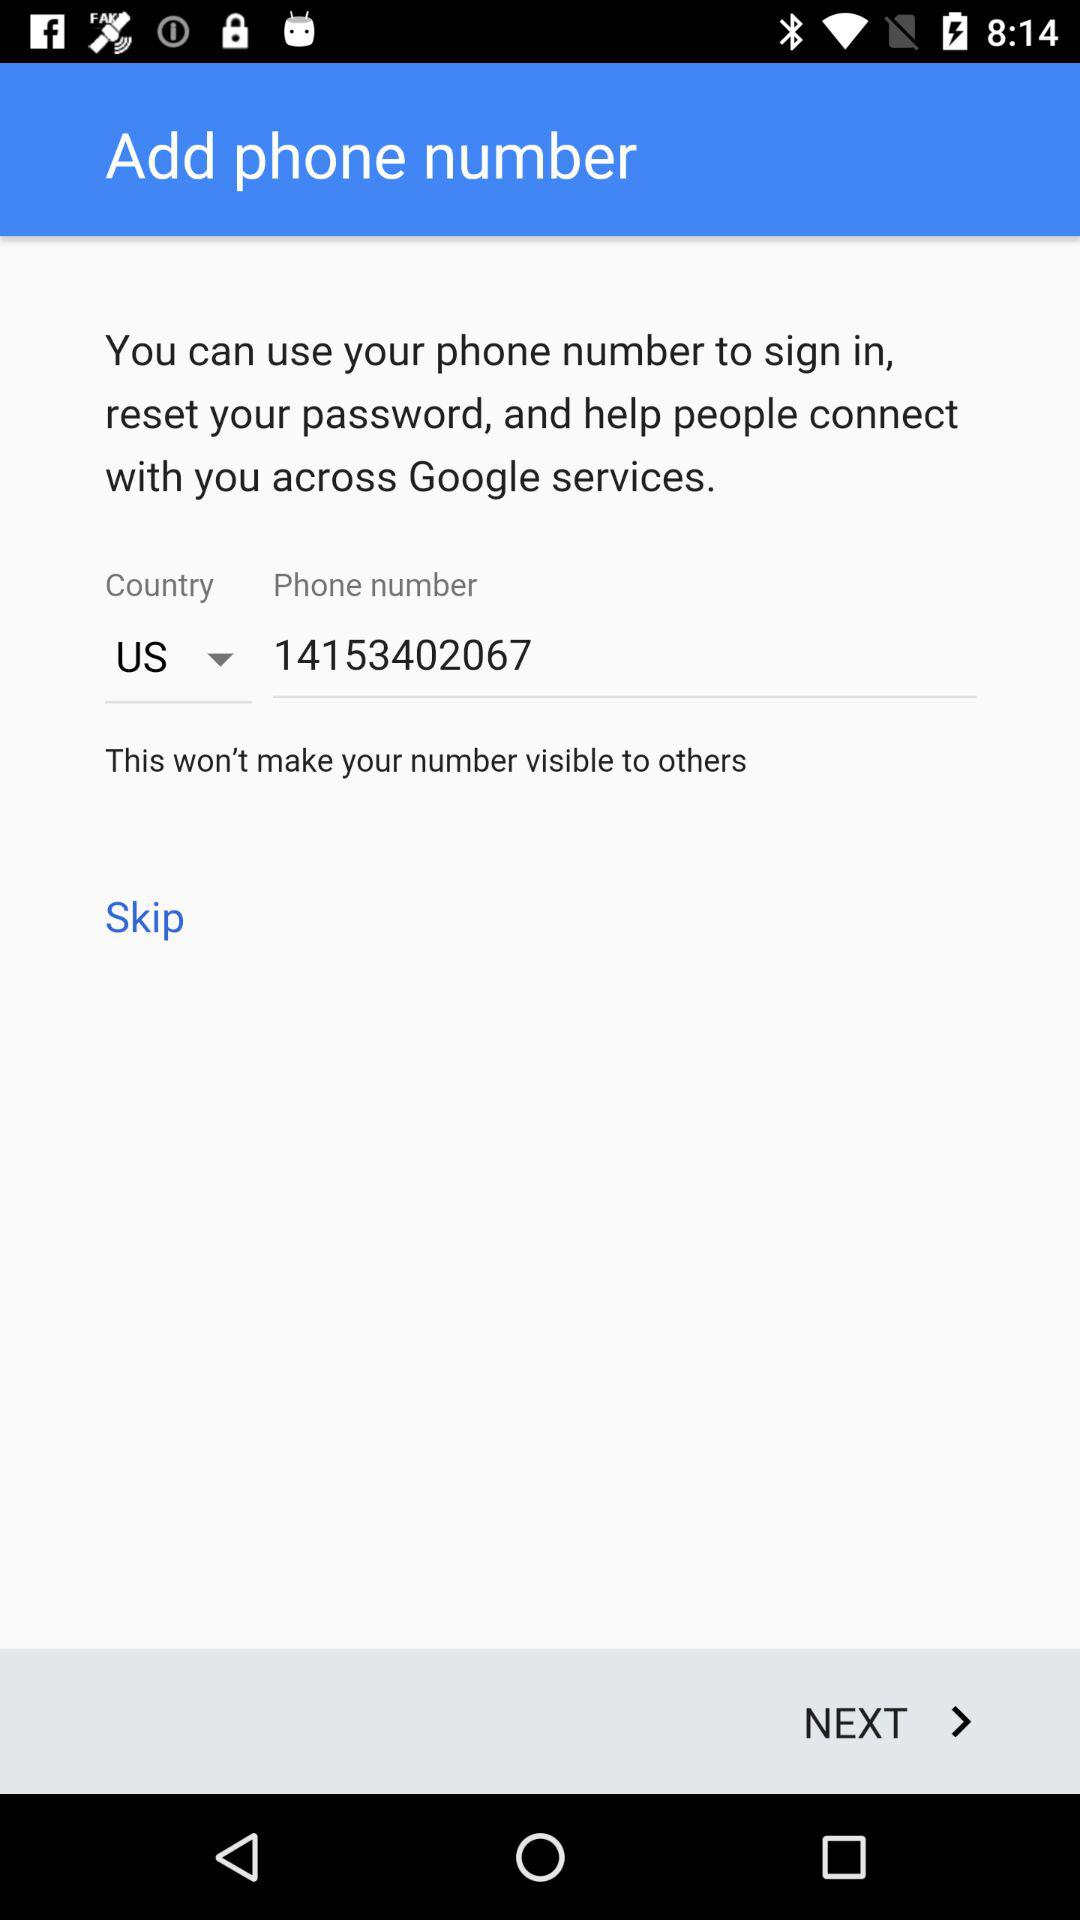What is the country name? The name of the country is United States. 